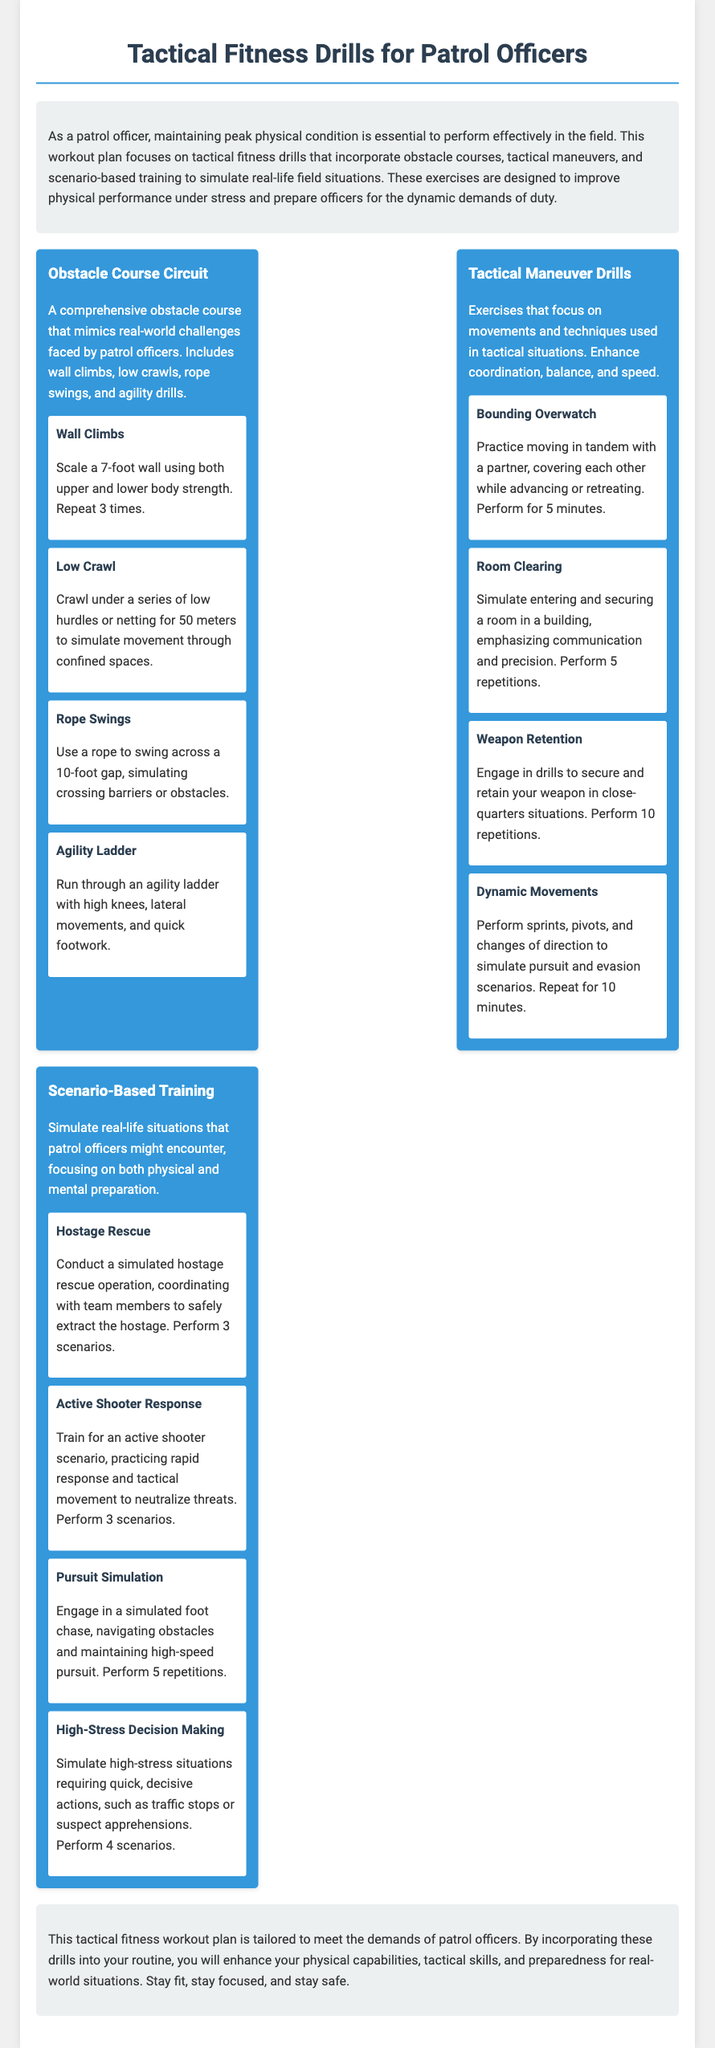What is the title of the document? The title is found at the top of the document and summarizes the content it covers.
Answer: Tactical Fitness Drills for Patrol Officers How many workout sections are there? The number of workout sections is indicated by the headings within the workout plan.
Answer: 3 What equipment is needed for the Rope Swings drill? The equipment needed for specific drills can usually be found in the description of that drill.
Answer: Rope How many repetitions are required for Weapon Retention? The number of repetitions is included in the description of that particular drill.
Answer: 10 What is the focus of Scenario-Based Training? The focus is mentioned in the heading and is often elaborated in the description that follows.
Answer: Simulate real-life situations What type of scenarios are practiced in the Active Shooter Response drill? The type of scenarios is specified in the drill's description, highlighting the nature of the training.
Answer: Active shooter What does the conclusion advise officers to do? The conclusion summarizes the overall goal of the workout plan and gives advice to officers.
Answer: Stay fit, stay focused, and stay safe How long should the Bounding Overwatch drill be performed? The duration for which drills should be performed is stated explicitly within the drill's instructions.
Answer: 5 minutes What exercise follows the Low Crawl in the Obstacle Course Circuit? The sequence of exercises is detailed in the workout section under the Obstacle Course Circuit.
Answer: Rope Swings 